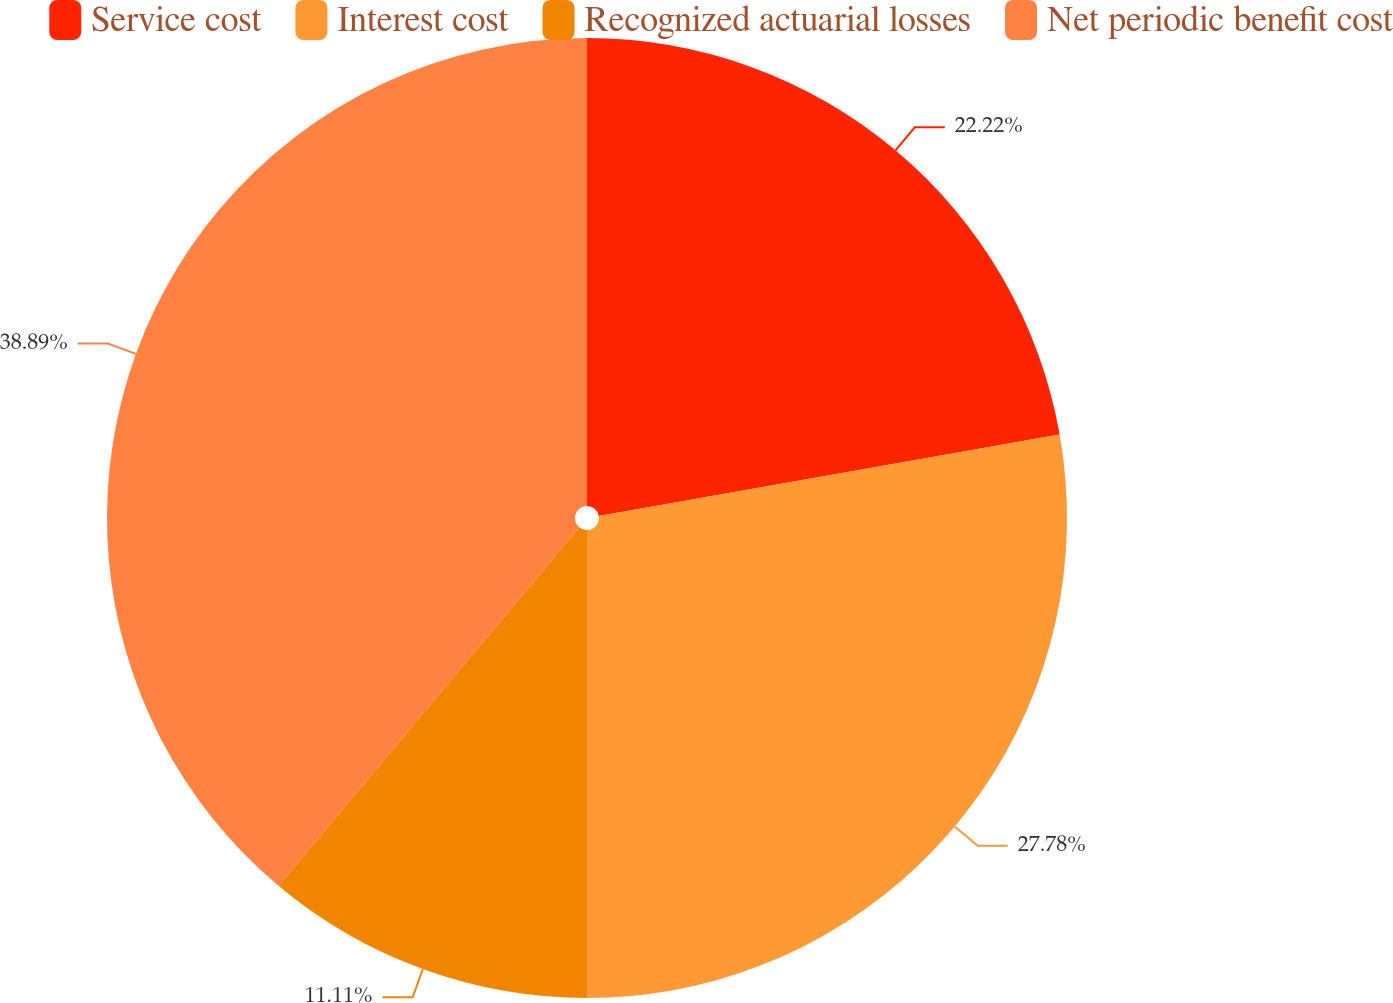Convert chart to OTSL. <chart><loc_0><loc_0><loc_500><loc_500><pie_chart><fcel>Service cost<fcel>Interest cost<fcel>Recognized actuarial losses<fcel>Net periodic benefit cost<nl><fcel>22.22%<fcel>27.78%<fcel>11.11%<fcel>38.89%<nl></chart> 